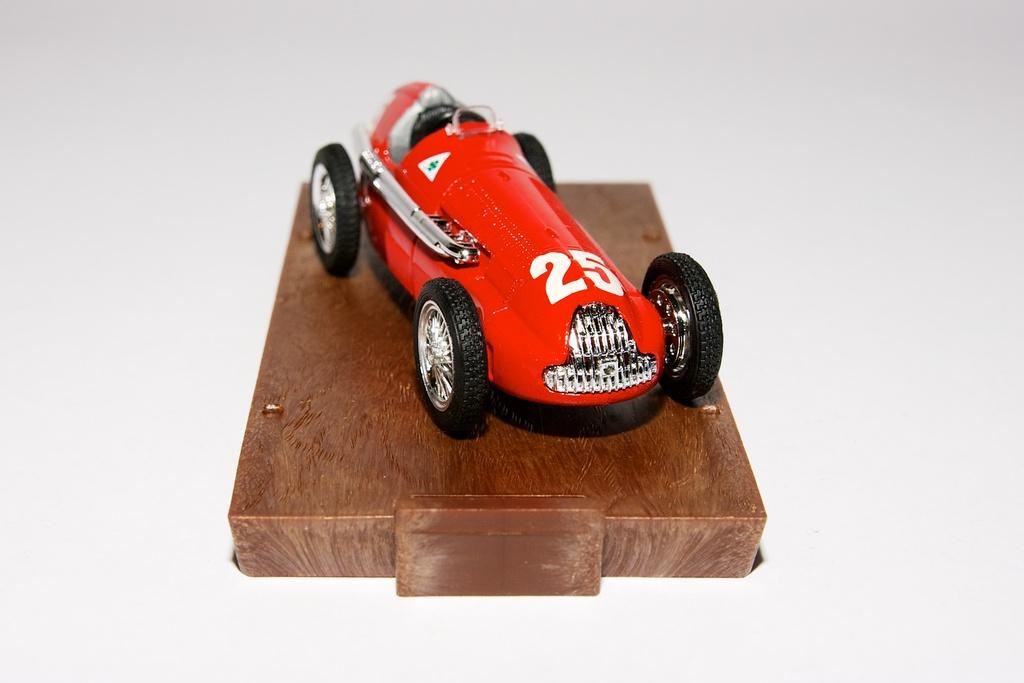What type of toy is in the image? There is a red toy car in the image. What is the red toy car placed on? The red toy car is on a wooden block. What color is the surface visible in the image? The surface in the image is white. What type of nation is represented by the red toy car in the image? The image does not represent any nation, as it features a red toy car on a wooden block and a white surface. What type of jeans is the red toy car wearing in the image? The red toy car is not a living being and therefore cannot wear jeans. 